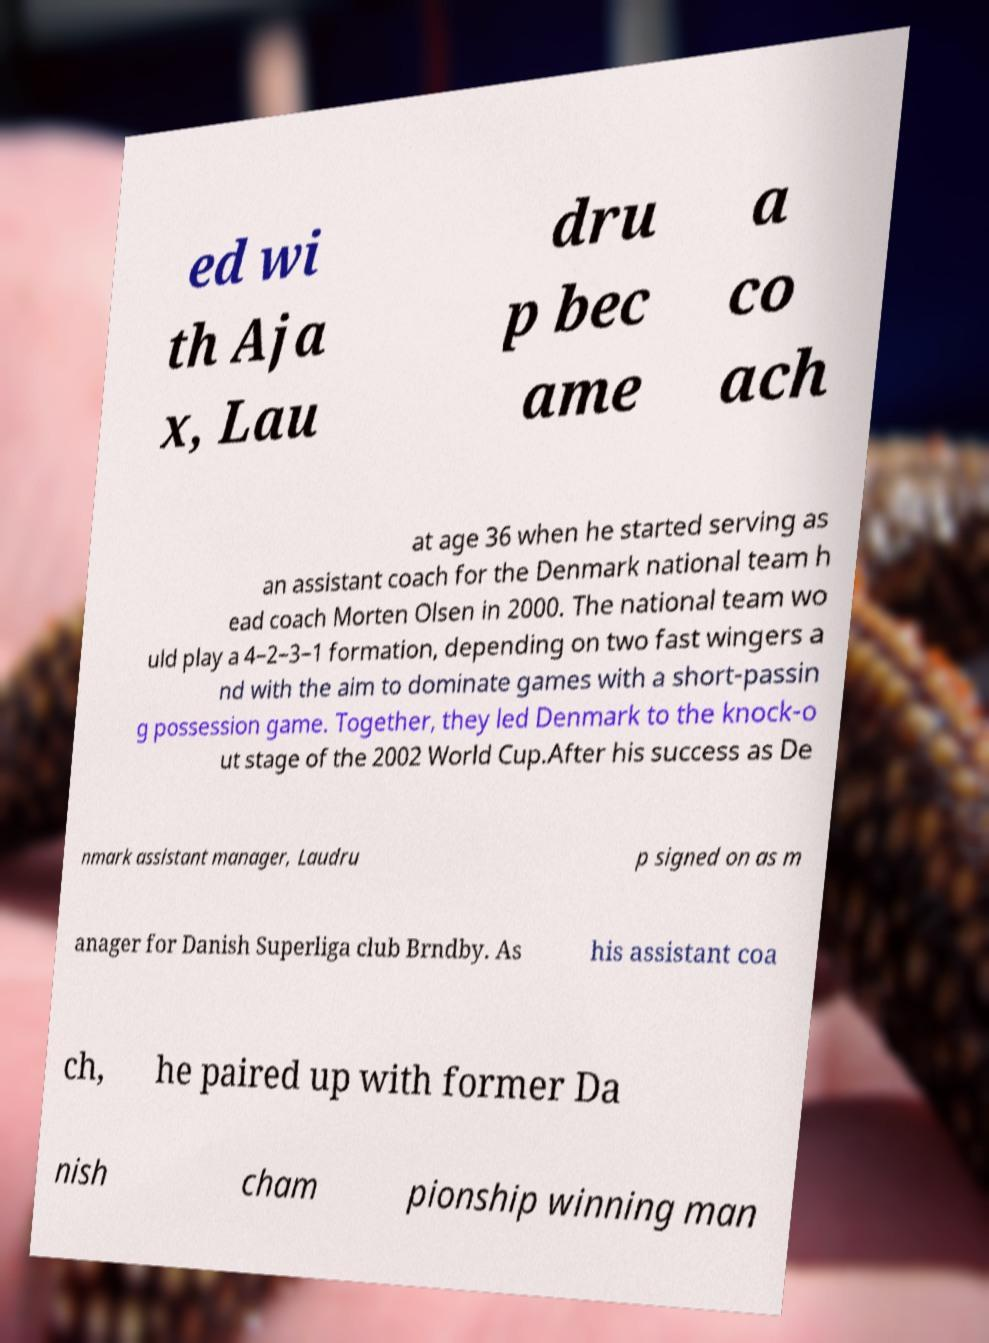There's text embedded in this image that I need extracted. Can you transcribe it verbatim? ed wi th Aja x, Lau dru p bec ame a co ach at age 36 when he started serving as an assistant coach for the Denmark national team h ead coach Morten Olsen in 2000. The national team wo uld play a 4–2–3–1 formation, depending on two fast wingers a nd with the aim to dominate games with a short-passin g possession game. Together, they led Denmark to the knock-o ut stage of the 2002 World Cup.After his success as De nmark assistant manager, Laudru p signed on as m anager for Danish Superliga club Brndby. As his assistant coa ch, he paired up with former Da nish cham pionship winning man 